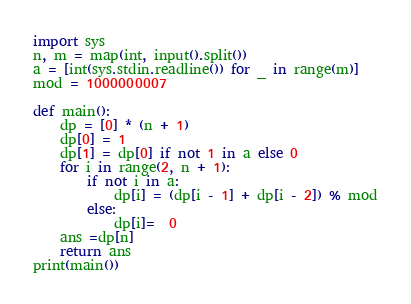<code> <loc_0><loc_0><loc_500><loc_500><_Python_>import sys
n, m = map(int, input().split())
a = [int(sys.stdin.readline()) for _ in range(m)]
mod = 1000000007

def main():
    dp = [0] * (n + 1)
    dp[0] = 1
    dp[1] = dp[0] if not 1 in a else 0
    for i in range(2, n + 1):
        if not i in a:
            dp[i] = (dp[i - 1] + dp[i - 2]) % mod
        else:
            dp[i]=  0
    ans =dp[n]
    return ans
print(main())
</code> 